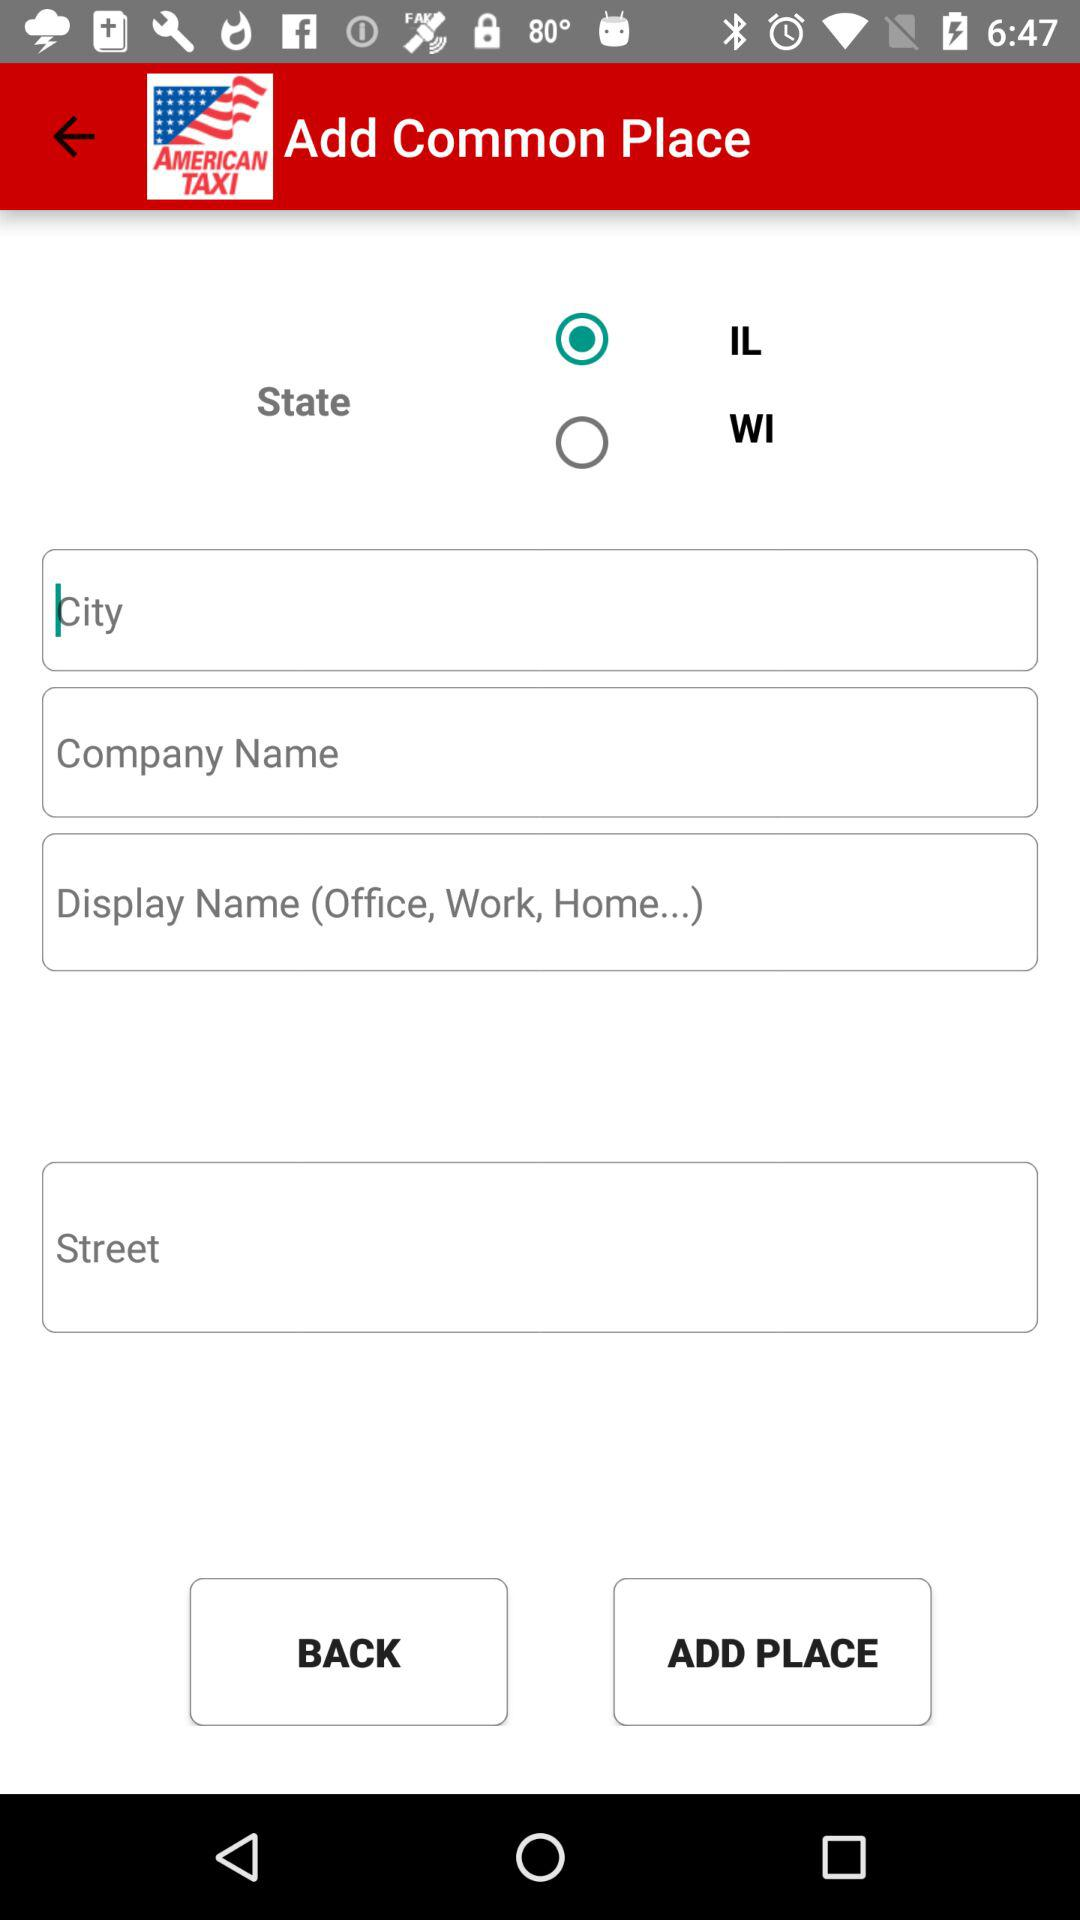Which state is selected? The selected state is IL. 